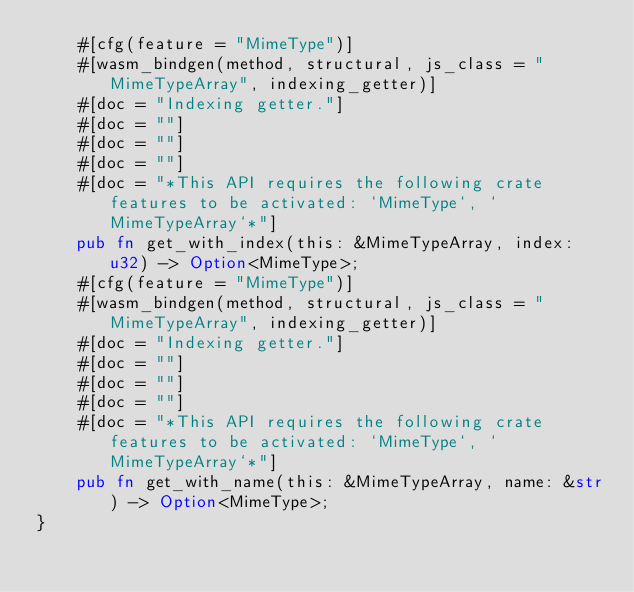<code> <loc_0><loc_0><loc_500><loc_500><_Rust_>    #[cfg(feature = "MimeType")]
    #[wasm_bindgen(method, structural, js_class = "MimeTypeArray", indexing_getter)]
    #[doc = "Indexing getter."]
    #[doc = ""]
    #[doc = ""]
    #[doc = ""]
    #[doc = "*This API requires the following crate features to be activated: `MimeType`, `MimeTypeArray`*"]
    pub fn get_with_index(this: &MimeTypeArray, index: u32) -> Option<MimeType>;
    #[cfg(feature = "MimeType")]
    #[wasm_bindgen(method, structural, js_class = "MimeTypeArray", indexing_getter)]
    #[doc = "Indexing getter."]
    #[doc = ""]
    #[doc = ""]
    #[doc = ""]
    #[doc = "*This API requires the following crate features to be activated: `MimeType`, `MimeTypeArray`*"]
    pub fn get_with_name(this: &MimeTypeArray, name: &str) -> Option<MimeType>;
}
</code> 